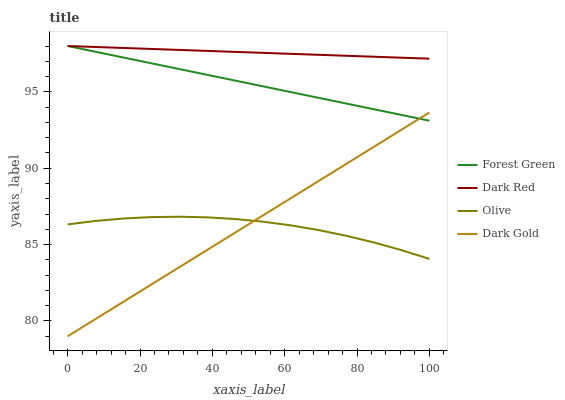Does Olive have the minimum area under the curve?
Answer yes or no. Yes. Does Dark Red have the maximum area under the curve?
Answer yes or no. Yes. Does Forest Green have the minimum area under the curve?
Answer yes or no. No. Does Forest Green have the maximum area under the curve?
Answer yes or no. No. Is Forest Green the smoothest?
Answer yes or no. Yes. Is Olive the roughest?
Answer yes or no. Yes. Is Dark Red the smoothest?
Answer yes or no. No. Is Dark Red the roughest?
Answer yes or no. No. Does Dark Gold have the lowest value?
Answer yes or no. Yes. Does Forest Green have the lowest value?
Answer yes or no. No. Does Forest Green have the highest value?
Answer yes or no. Yes. Does Dark Gold have the highest value?
Answer yes or no. No. Is Olive less than Dark Red?
Answer yes or no. Yes. Is Forest Green greater than Olive?
Answer yes or no. Yes. Does Dark Gold intersect Olive?
Answer yes or no. Yes. Is Dark Gold less than Olive?
Answer yes or no. No. Is Dark Gold greater than Olive?
Answer yes or no. No. Does Olive intersect Dark Red?
Answer yes or no. No. 